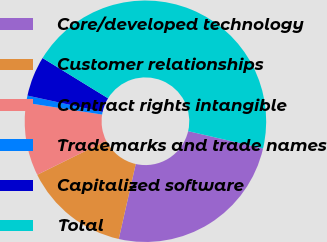<chart> <loc_0><loc_0><loc_500><loc_500><pie_chart><fcel>Core/developed technology<fcel>Customer relationships<fcel>Contract rights intangible<fcel>Trademarks and trade names<fcel>Capitalized software<fcel>Total<nl><fcel>24.92%<fcel>14.14%<fcel>9.75%<fcel>0.97%<fcel>5.36%<fcel>44.85%<nl></chart> 